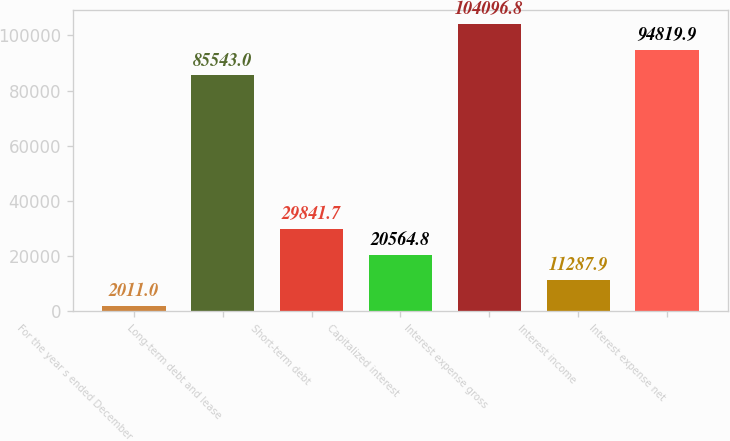Convert chart. <chart><loc_0><loc_0><loc_500><loc_500><bar_chart><fcel>For the year s ended December<fcel>Long-term debt and lease<fcel>Short-term debt<fcel>Capitalized interest<fcel>Interest expense gross<fcel>Interest income<fcel>Interest expense net<nl><fcel>2011<fcel>85543<fcel>29841.7<fcel>20564.8<fcel>104097<fcel>11287.9<fcel>94819.9<nl></chart> 